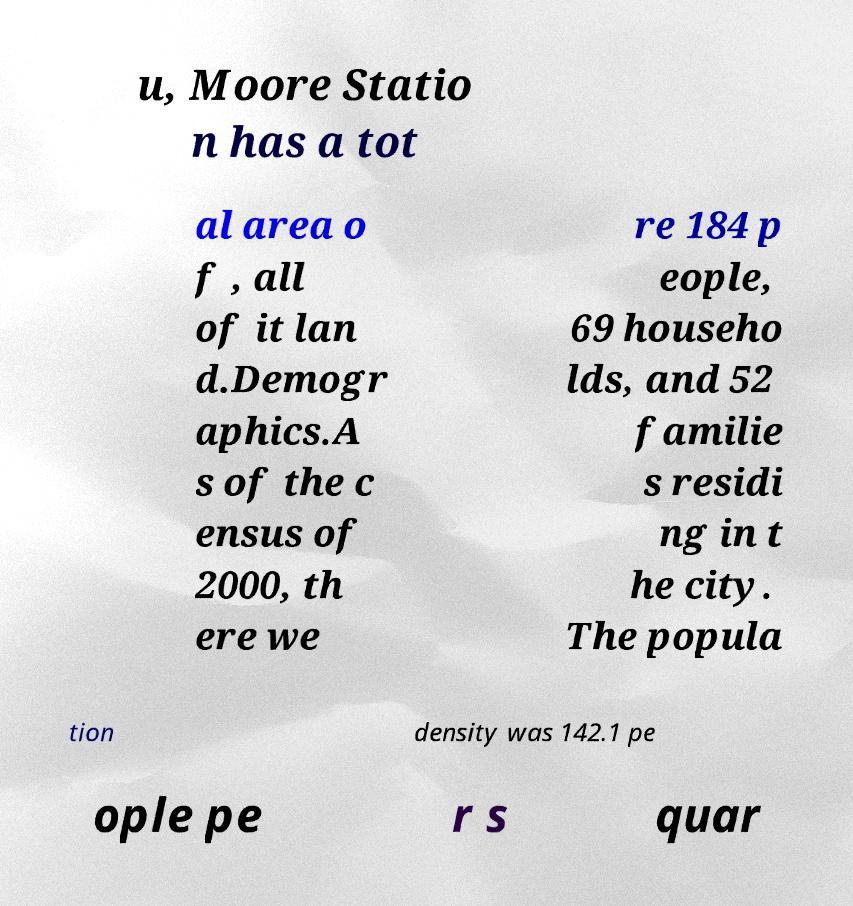There's text embedded in this image that I need extracted. Can you transcribe it verbatim? u, Moore Statio n has a tot al area o f , all of it lan d.Demogr aphics.A s of the c ensus of 2000, th ere we re 184 p eople, 69 househo lds, and 52 familie s residi ng in t he city. The popula tion density was 142.1 pe ople pe r s quar 